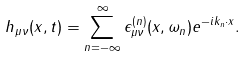<formula> <loc_0><loc_0><loc_500><loc_500>h _ { \mu \nu } ( { x } , t ) = \sum _ { n = - \infty } ^ { \infty } \epsilon _ { \mu \nu } ^ { ( n ) } ( { x } , \omega _ { n } ) e ^ { - i k _ { n } \cdot x } .</formula> 